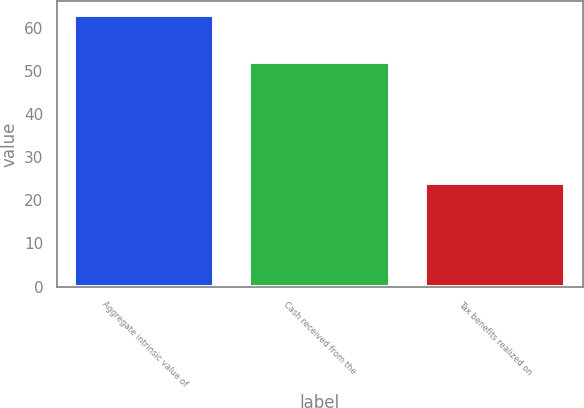Convert chart to OTSL. <chart><loc_0><loc_0><loc_500><loc_500><bar_chart><fcel>Aggregate intrinsic value of<fcel>Cash received from the<fcel>Tax benefits realized on<nl><fcel>63<fcel>52<fcel>24<nl></chart> 